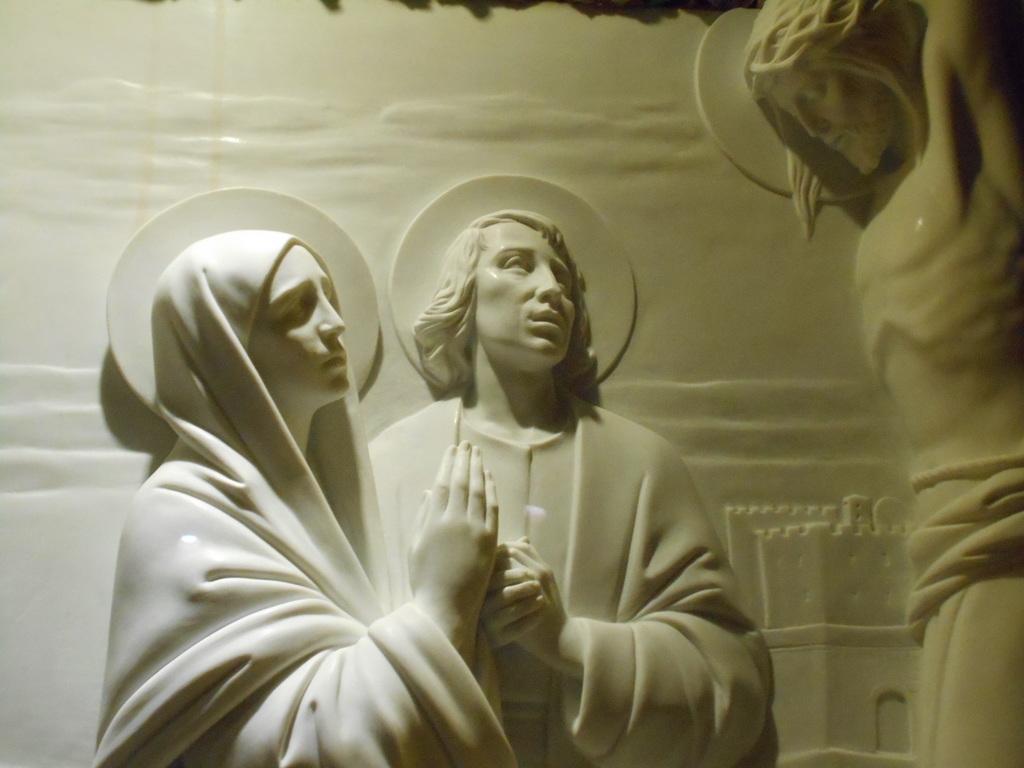In one or two sentences, can you explain what this image depicts? In the picture we can see a sculpture on the wall of a man and a woman and Jesus which is white in color. 